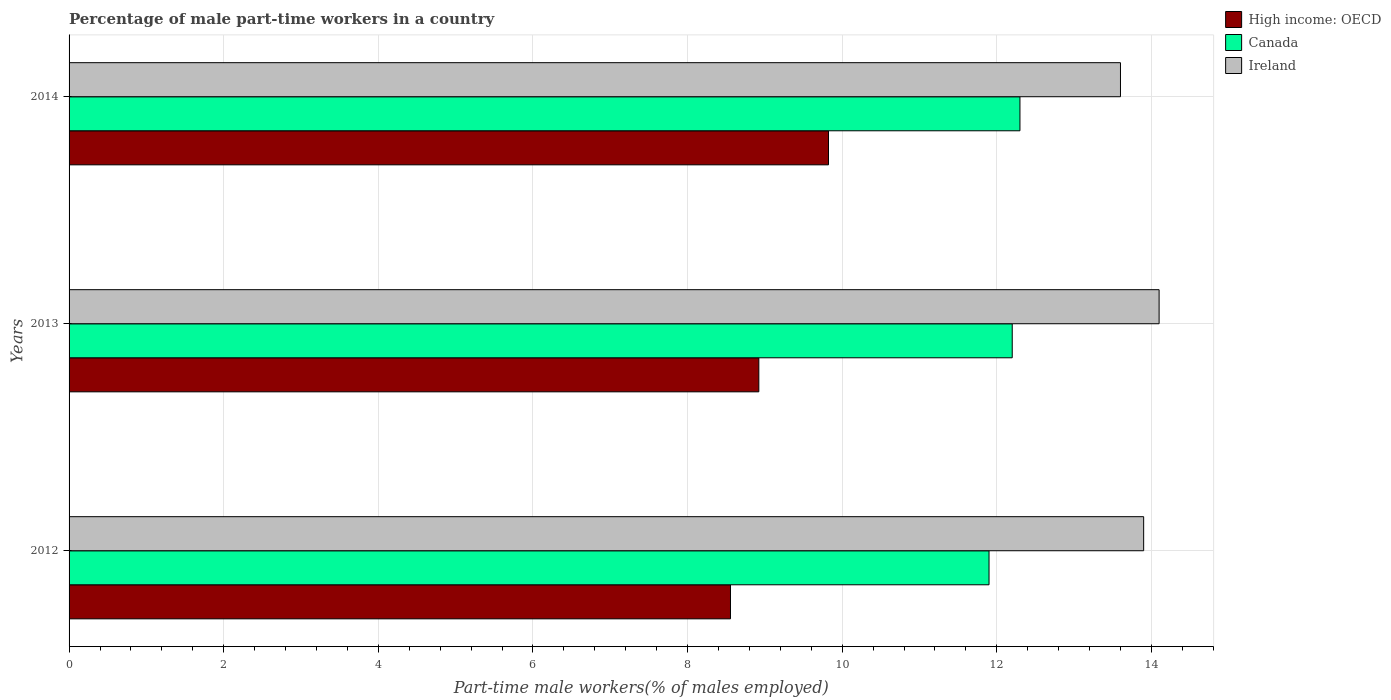How many different coloured bars are there?
Keep it short and to the point. 3. Are the number of bars per tick equal to the number of legend labels?
Provide a short and direct response. Yes. What is the percentage of male part-time workers in High income: OECD in 2012?
Offer a very short reply. 8.56. Across all years, what is the maximum percentage of male part-time workers in High income: OECD?
Offer a very short reply. 9.82. Across all years, what is the minimum percentage of male part-time workers in Ireland?
Your response must be concise. 13.6. In which year was the percentage of male part-time workers in Ireland maximum?
Your answer should be very brief. 2013. What is the total percentage of male part-time workers in Ireland in the graph?
Your answer should be compact. 41.6. What is the difference between the percentage of male part-time workers in High income: OECD in 2012 and that in 2014?
Keep it short and to the point. -1.27. What is the difference between the percentage of male part-time workers in Canada in 2013 and the percentage of male part-time workers in High income: OECD in 2012?
Ensure brevity in your answer.  3.64. What is the average percentage of male part-time workers in High income: OECD per year?
Provide a short and direct response. 9.1. In the year 2012, what is the difference between the percentage of male part-time workers in Canada and percentage of male part-time workers in High income: OECD?
Ensure brevity in your answer.  3.34. In how many years, is the percentage of male part-time workers in High income: OECD greater than 4.4 %?
Provide a succinct answer. 3. What is the ratio of the percentage of male part-time workers in High income: OECD in 2012 to that in 2013?
Your response must be concise. 0.96. What is the difference between the highest and the second highest percentage of male part-time workers in Ireland?
Provide a short and direct response. 0.2. What is the difference between the highest and the lowest percentage of male part-time workers in High income: OECD?
Your response must be concise. 1.27. In how many years, is the percentage of male part-time workers in Canada greater than the average percentage of male part-time workers in Canada taken over all years?
Your answer should be very brief. 2. What does the 1st bar from the top in 2014 represents?
Provide a short and direct response. Ireland. What does the 3rd bar from the bottom in 2013 represents?
Make the answer very short. Ireland. Are all the bars in the graph horizontal?
Provide a short and direct response. Yes. How many years are there in the graph?
Offer a terse response. 3. What is the difference between two consecutive major ticks on the X-axis?
Provide a short and direct response. 2. Are the values on the major ticks of X-axis written in scientific E-notation?
Your response must be concise. No. Does the graph contain grids?
Ensure brevity in your answer.  Yes. How many legend labels are there?
Your answer should be compact. 3. What is the title of the graph?
Your answer should be very brief. Percentage of male part-time workers in a country. What is the label or title of the X-axis?
Offer a very short reply. Part-time male workers(% of males employed). What is the Part-time male workers(% of males employed) of High income: OECD in 2012?
Provide a short and direct response. 8.56. What is the Part-time male workers(% of males employed) in Canada in 2012?
Provide a short and direct response. 11.9. What is the Part-time male workers(% of males employed) of Ireland in 2012?
Provide a short and direct response. 13.9. What is the Part-time male workers(% of males employed) in High income: OECD in 2013?
Provide a succinct answer. 8.92. What is the Part-time male workers(% of males employed) of Canada in 2013?
Keep it short and to the point. 12.2. What is the Part-time male workers(% of males employed) in Ireland in 2013?
Offer a terse response. 14.1. What is the Part-time male workers(% of males employed) in High income: OECD in 2014?
Offer a very short reply. 9.82. What is the Part-time male workers(% of males employed) in Canada in 2014?
Offer a very short reply. 12.3. What is the Part-time male workers(% of males employed) of Ireland in 2014?
Provide a succinct answer. 13.6. Across all years, what is the maximum Part-time male workers(% of males employed) of High income: OECD?
Provide a succinct answer. 9.82. Across all years, what is the maximum Part-time male workers(% of males employed) in Canada?
Your response must be concise. 12.3. Across all years, what is the maximum Part-time male workers(% of males employed) in Ireland?
Offer a very short reply. 14.1. Across all years, what is the minimum Part-time male workers(% of males employed) of High income: OECD?
Provide a short and direct response. 8.56. Across all years, what is the minimum Part-time male workers(% of males employed) of Canada?
Keep it short and to the point. 11.9. Across all years, what is the minimum Part-time male workers(% of males employed) of Ireland?
Make the answer very short. 13.6. What is the total Part-time male workers(% of males employed) of High income: OECD in the graph?
Keep it short and to the point. 27.3. What is the total Part-time male workers(% of males employed) in Canada in the graph?
Offer a very short reply. 36.4. What is the total Part-time male workers(% of males employed) of Ireland in the graph?
Provide a short and direct response. 41.6. What is the difference between the Part-time male workers(% of males employed) of High income: OECD in 2012 and that in 2013?
Keep it short and to the point. -0.37. What is the difference between the Part-time male workers(% of males employed) in Ireland in 2012 and that in 2013?
Your response must be concise. -0.2. What is the difference between the Part-time male workers(% of males employed) of High income: OECD in 2012 and that in 2014?
Ensure brevity in your answer.  -1.27. What is the difference between the Part-time male workers(% of males employed) in Ireland in 2012 and that in 2014?
Your answer should be very brief. 0.3. What is the difference between the Part-time male workers(% of males employed) in High income: OECD in 2013 and that in 2014?
Give a very brief answer. -0.9. What is the difference between the Part-time male workers(% of males employed) in Ireland in 2013 and that in 2014?
Your response must be concise. 0.5. What is the difference between the Part-time male workers(% of males employed) of High income: OECD in 2012 and the Part-time male workers(% of males employed) of Canada in 2013?
Your answer should be compact. -3.64. What is the difference between the Part-time male workers(% of males employed) of High income: OECD in 2012 and the Part-time male workers(% of males employed) of Ireland in 2013?
Your response must be concise. -5.54. What is the difference between the Part-time male workers(% of males employed) in High income: OECD in 2012 and the Part-time male workers(% of males employed) in Canada in 2014?
Provide a short and direct response. -3.74. What is the difference between the Part-time male workers(% of males employed) of High income: OECD in 2012 and the Part-time male workers(% of males employed) of Ireland in 2014?
Make the answer very short. -5.04. What is the difference between the Part-time male workers(% of males employed) in High income: OECD in 2013 and the Part-time male workers(% of males employed) in Canada in 2014?
Make the answer very short. -3.38. What is the difference between the Part-time male workers(% of males employed) in High income: OECD in 2013 and the Part-time male workers(% of males employed) in Ireland in 2014?
Make the answer very short. -4.68. What is the average Part-time male workers(% of males employed) in High income: OECD per year?
Keep it short and to the point. 9.1. What is the average Part-time male workers(% of males employed) of Canada per year?
Keep it short and to the point. 12.13. What is the average Part-time male workers(% of males employed) of Ireland per year?
Offer a very short reply. 13.87. In the year 2012, what is the difference between the Part-time male workers(% of males employed) of High income: OECD and Part-time male workers(% of males employed) of Canada?
Ensure brevity in your answer.  -3.34. In the year 2012, what is the difference between the Part-time male workers(% of males employed) in High income: OECD and Part-time male workers(% of males employed) in Ireland?
Your response must be concise. -5.34. In the year 2013, what is the difference between the Part-time male workers(% of males employed) in High income: OECD and Part-time male workers(% of males employed) in Canada?
Provide a short and direct response. -3.28. In the year 2013, what is the difference between the Part-time male workers(% of males employed) in High income: OECD and Part-time male workers(% of males employed) in Ireland?
Your response must be concise. -5.18. In the year 2013, what is the difference between the Part-time male workers(% of males employed) in Canada and Part-time male workers(% of males employed) in Ireland?
Provide a short and direct response. -1.9. In the year 2014, what is the difference between the Part-time male workers(% of males employed) of High income: OECD and Part-time male workers(% of males employed) of Canada?
Offer a terse response. -2.48. In the year 2014, what is the difference between the Part-time male workers(% of males employed) of High income: OECD and Part-time male workers(% of males employed) of Ireland?
Your answer should be very brief. -3.78. What is the ratio of the Part-time male workers(% of males employed) in High income: OECD in 2012 to that in 2013?
Your answer should be compact. 0.96. What is the ratio of the Part-time male workers(% of males employed) of Canada in 2012 to that in 2013?
Give a very brief answer. 0.98. What is the ratio of the Part-time male workers(% of males employed) in Ireland in 2012 to that in 2013?
Give a very brief answer. 0.99. What is the ratio of the Part-time male workers(% of males employed) in High income: OECD in 2012 to that in 2014?
Provide a short and direct response. 0.87. What is the ratio of the Part-time male workers(% of males employed) in Canada in 2012 to that in 2014?
Offer a very short reply. 0.97. What is the ratio of the Part-time male workers(% of males employed) of Ireland in 2012 to that in 2014?
Give a very brief answer. 1.02. What is the ratio of the Part-time male workers(% of males employed) in High income: OECD in 2013 to that in 2014?
Give a very brief answer. 0.91. What is the ratio of the Part-time male workers(% of males employed) in Canada in 2013 to that in 2014?
Give a very brief answer. 0.99. What is the ratio of the Part-time male workers(% of males employed) in Ireland in 2013 to that in 2014?
Keep it short and to the point. 1.04. What is the difference between the highest and the second highest Part-time male workers(% of males employed) of High income: OECD?
Give a very brief answer. 0.9. What is the difference between the highest and the second highest Part-time male workers(% of males employed) in Canada?
Offer a very short reply. 0.1. What is the difference between the highest and the second highest Part-time male workers(% of males employed) in Ireland?
Provide a short and direct response. 0.2. What is the difference between the highest and the lowest Part-time male workers(% of males employed) in High income: OECD?
Your answer should be compact. 1.27. 